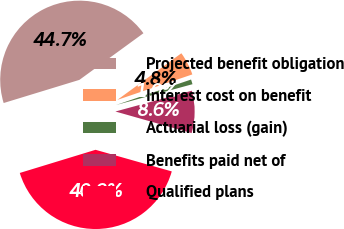<chart> <loc_0><loc_0><loc_500><loc_500><pie_chart><fcel>Projected benefit obligation<fcel>Interest cost on benefit<fcel>Actuarial loss (gain)<fcel>Benefits paid net of<fcel>Qualified plans<nl><fcel>44.7%<fcel>4.81%<fcel>0.98%<fcel>8.63%<fcel>40.88%<nl></chart> 